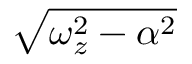<formula> <loc_0><loc_0><loc_500><loc_500>\sqrt { \omega _ { z } ^ { 2 } - \alpha ^ { 2 } }</formula> 